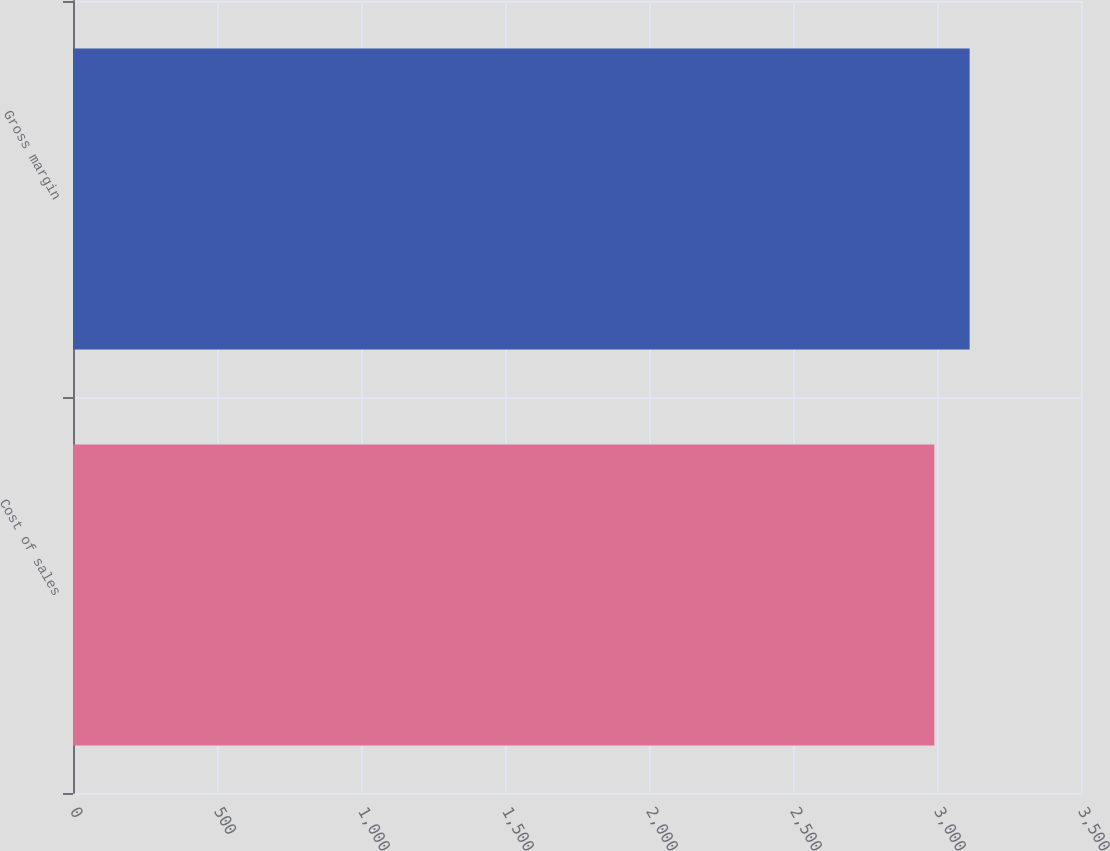<chart> <loc_0><loc_0><loc_500><loc_500><bar_chart><fcel>Cost of sales<fcel>Gross margin<nl><fcel>2990.7<fcel>3113.3<nl></chart> 